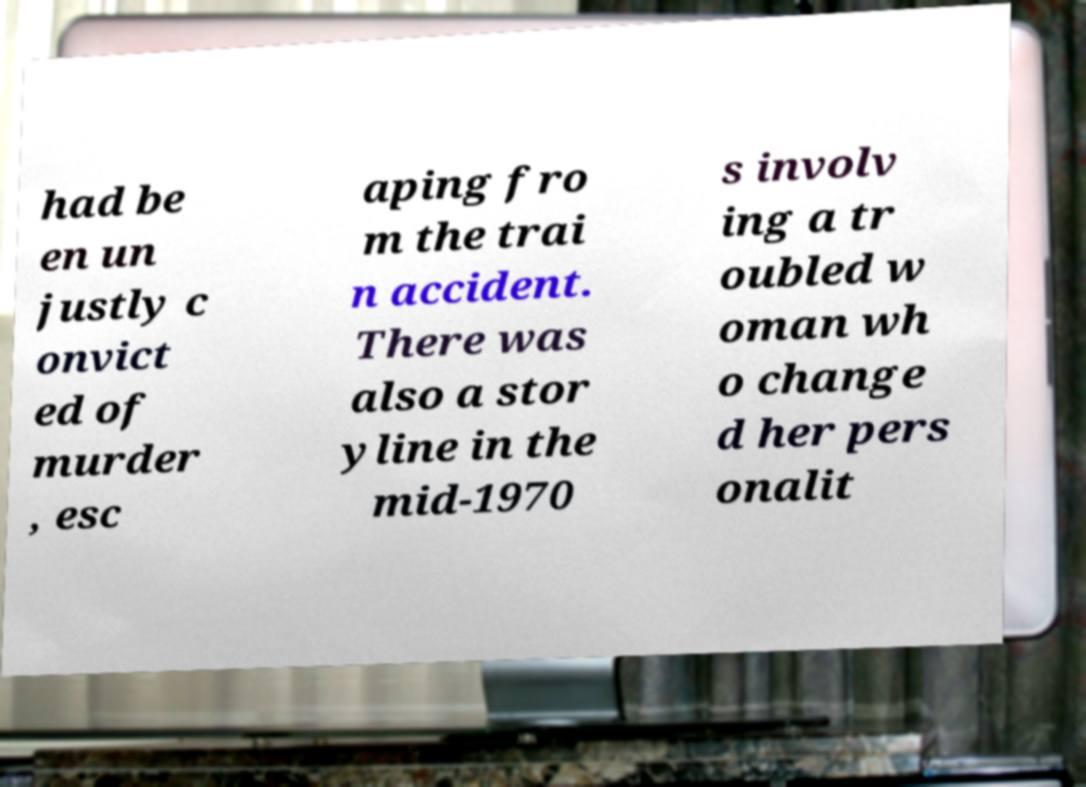Could you extract and type out the text from this image? had be en un justly c onvict ed of murder , esc aping fro m the trai n accident. There was also a stor yline in the mid-1970 s involv ing a tr oubled w oman wh o change d her pers onalit 